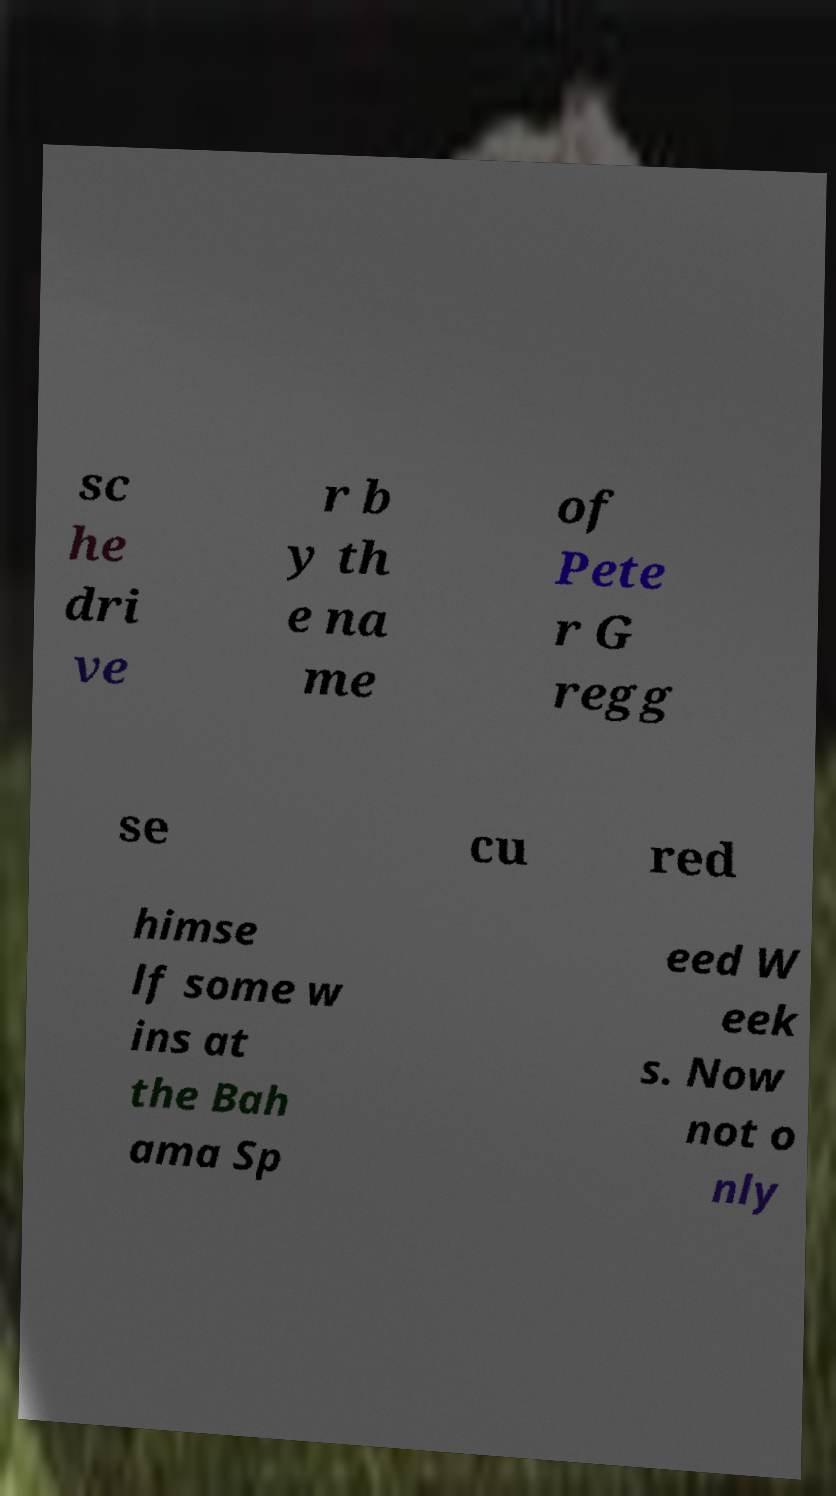Please identify and transcribe the text found in this image. sc he dri ve r b y th e na me of Pete r G regg se cu red himse lf some w ins at the Bah ama Sp eed W eek s. Now not o nly 